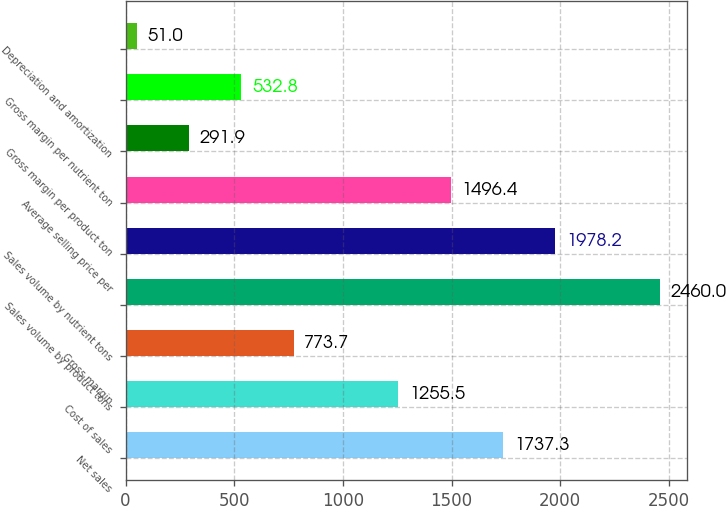<chart> <loc_0><loc_0><loc_500><loc_500><bar_chart><fcel>Net sales<fcel>Cost of sales<fcel>Gross margin<fcel>Sales volume by product tons<fcel>Sales volume by nutrient tons<fcel>Average selling price per<fcel>Gross margin per product ton<fcel>Gross margin per nutrient ton<fcel>Depreciation and amortization<nl><fcel>1737.3<fcel>1255.5<fcel>773.7<fcel>2460<fcel>1978.2<fcel>1496.4<fcel>291.9<fcel>532.8<fcel>51<nl></chart> 